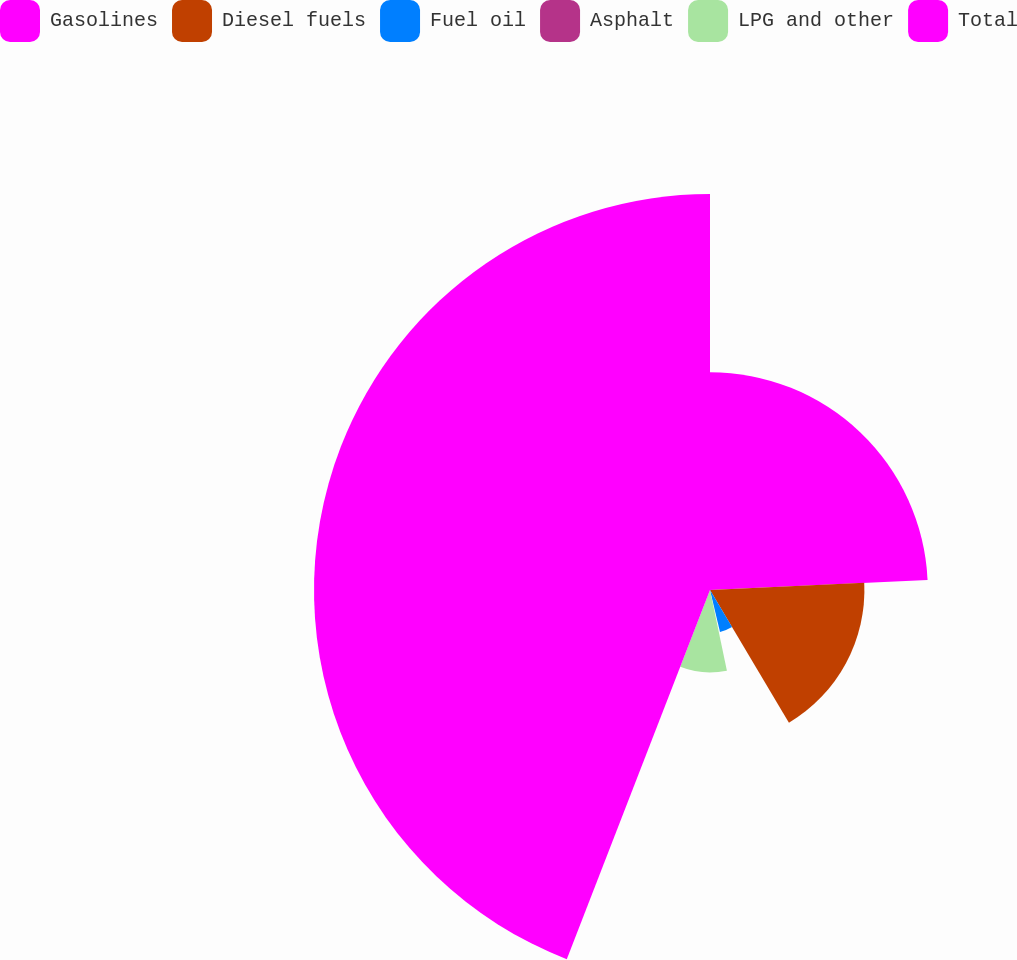Convert chart to OTSL. <chart><loc_0><loc_0><loc_500><loc_500><pie_chart><fcel>Gasolines<fcel>Diesel fuels<fcel>Fuel oil<fcel>Asphalt<fcel>LPG and other<fcel>Total<nl><fcel>24.26%<fcel>17.2%<fcel>4.81%<fcel>0.44%<fcel>9.18%<fcel>44.11%<nl></chart> 